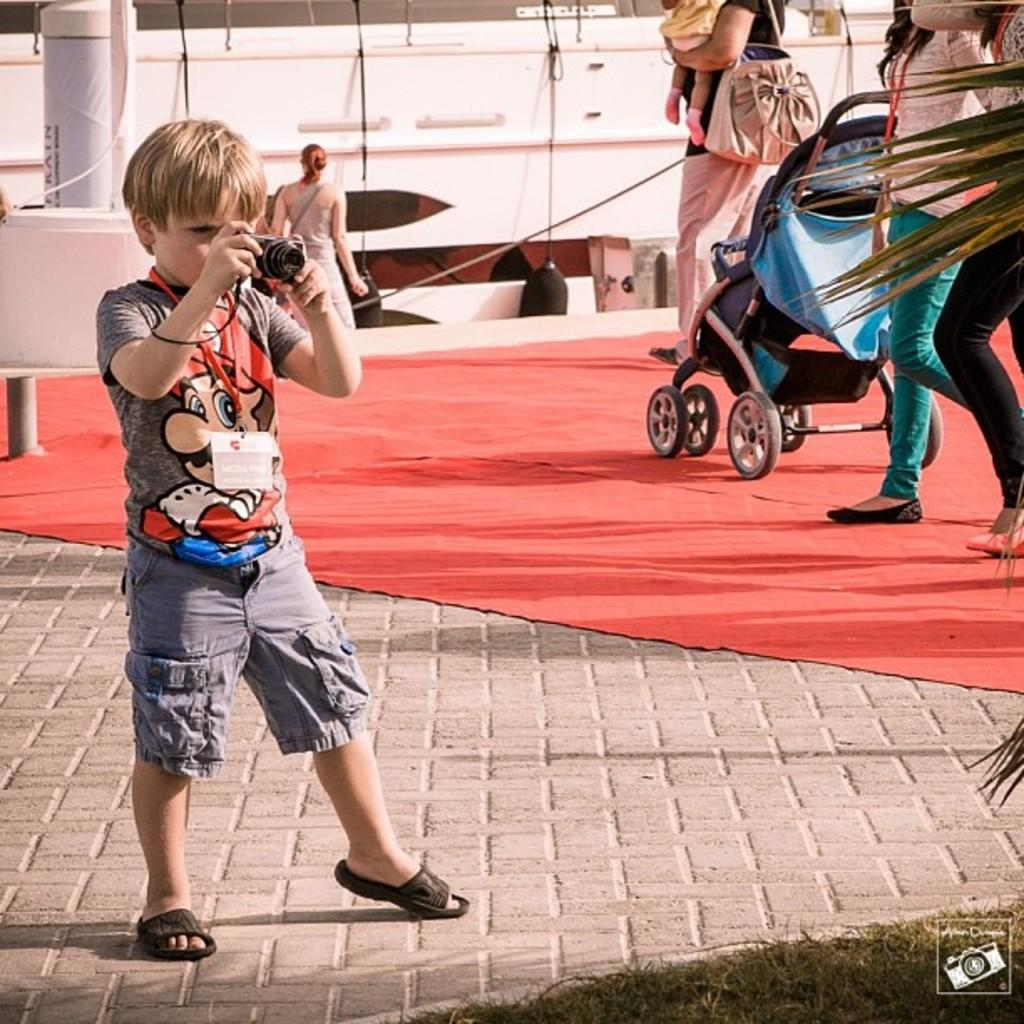What is the boy in the image doing? The boy is taking a photograph. What is the boy wearing in the image? The boy is wearing a grey t-shirt and grey shorts. Who else is present in the image besides the boy? There are two women in the image. What are the women doing in the image? The women are walking on a red carpet. What else can be seen in the image? There is a baby pram in the image. What type of punishment is being given to the baby in the pram? There is no baby in the pram in the image, and therefore no punishment is being given. What territory is being claimed by the boy in the image? There is no mention of territory in the image, and the boy is simply taking a photograph. 